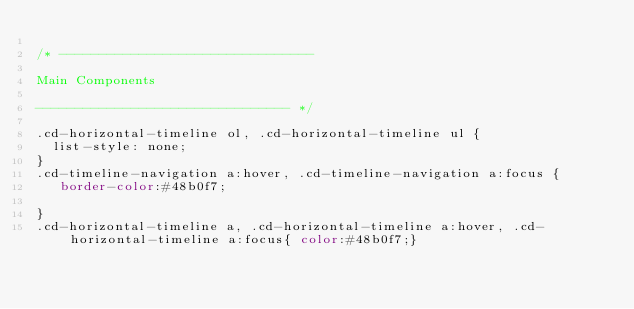Convert code to text. <code><loc_0><loc_0><loc_500><loc_500><_CSS_>
/* -------------------------------- 

Main Components 

-------------------------------- */

.cd-horizontal-timeline ol, .cd-horizontal-timeline ul {
  list-style: none;
}
.cd-timeline-navigation a:hover, .cd-timeline-navigation a:focus {
   border-color:#48b0f7;
  
}
.cd-horizontal-timeline a, .cd-horizontal-timeline a:hover, .cd-horizontal-timeline a:focus{ color:#48b0f7;}</code> 